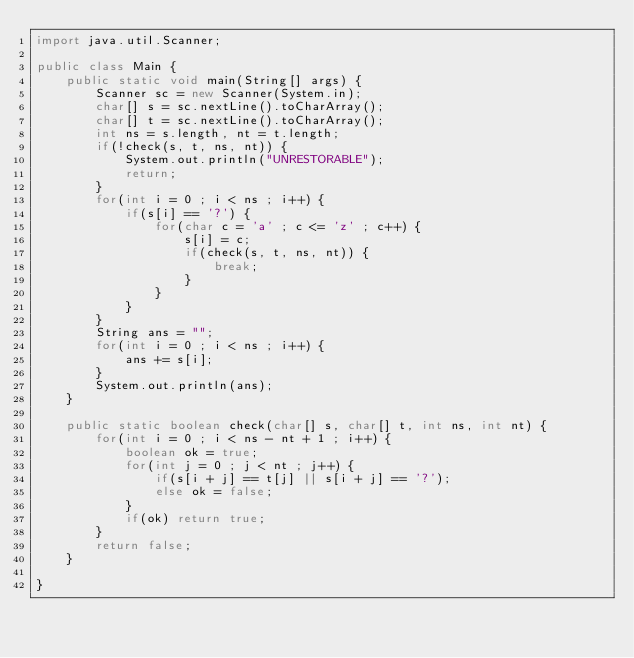Convert code to text. <code><loc_0><loc_0><loc_500><loc_500><_Java_>import java.util.Scanner;

public class Main {
	public static void main(String[] args) {
		Scanner sc = new Scanner(System.in);
		char[] s = sc.nextLine().toCharArray();
		char[] t = sc.nextLine().toCharArray();
		int ns = s.length, nt = t.length;
		if(!check(s, t, ns, nt)) {
			System.out.println("UNRESTORABLE");
			return;
		}
		for(int i = 0 ; i < ns ; i++) {
			if(s[i] == '?') {
				for(char c = 'a' ; c <= 'z' ; c++) {
					s[i] = c;
					if(check(s, t, ns, nt)) {
						break;
					}
				}
			}
		}
		String ans = "";
		for(int i = 0 ; i < ns ; i++) {
			ans += s[i];
		}
		System.out.println(ans);
	}

	public static boolean check(char[] s, char[] t, int ns, int nt) {
		for(int i = 0 ; i < ns - nt + 1 ; i++) {
			boolean ok = true;
			for(int j = 0 ; j < nt ; j++) {
				if(s[i + j] == t[j] || s[i + j] == '?');
				else ok = false;
			}
			if(ok) return true;
		}
		return false;
	}

}</code> 